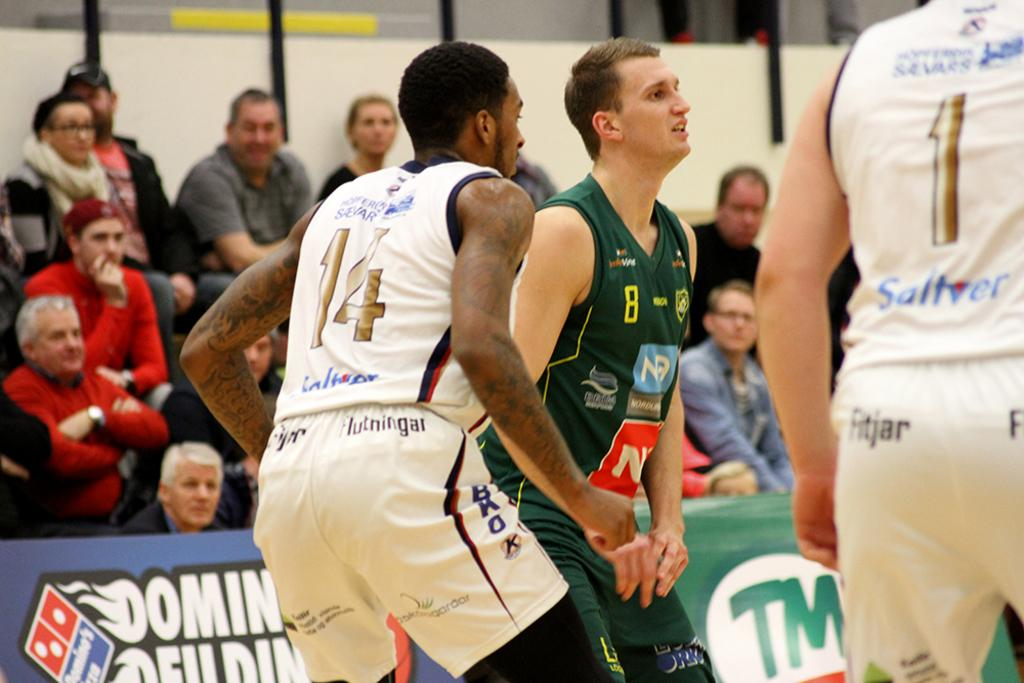<image>
Summarize the visual content of the image. A few basketball players playing and one wears 14 